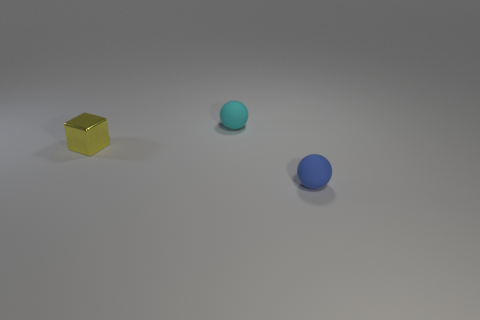Add 3 small yellow metal blocks. How many objects exist? 6 Subtract all blue spheres. How many spheres are left? 1 Subtract all cubes. How many objects are left? 2 Subtract 1 blocks. How many blocks are left? 0 Subtract all blue spheres. Subtract all yellow blocks. How many spheres are left? 1 Subtract all purple blocks. How many blue spheres are left? 1 Subtract all tiny blue matte blocks. Subtract all blue objects. How many objects are left? 2 Add 1 blue things. How many blue things are left? 2 Add 2 shiny blocks. How many shiny blocks exist? 3 Subtract 0 red spheres. How many objects are left? 3 